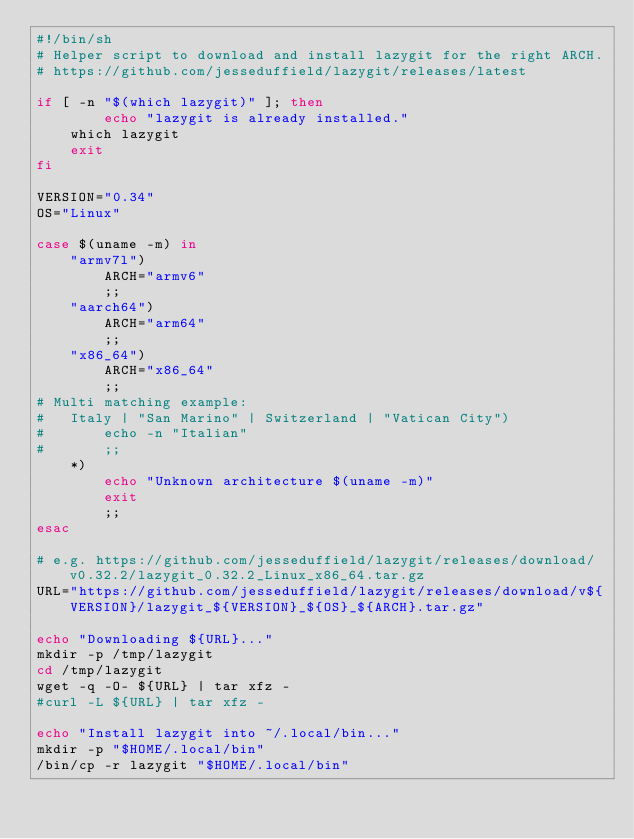<code> <loc_0><loc_0><loc_500><loc_500><_Bash_>#!/bin/sh
# Helper script to download and install lazygit for the right ARCH.
# https://github.com/jesseduffield/lazygit/releases/latest

if [ -n "$(which lazygit)" ]; then
        echo "lazygit is already installed."
	which lazygit
	exit
fi

VERSION="0.34"
OS="Linux"

case $(uname -m) in
	"armv7l")
		ARCH="armv6"
		;;
	"aarch64")
		ARCH="arm64"
		;;
	"x86_64")
		ARCH="x86_64"
		;;
# Multi matching example:
#	Italy | "San Marino" | Switzerland | "Vatican City")
#		echo -n "Italian"
#		;;
	*)
		echo "Unknown architecture $(uname -m)"
		exit
		;;
esac

# e.g. https://github.com/jesseduffield/lazygit/releases/download/v0.32.2/lazygit_0.32.2_Linux_x86_64.tar.gz
URL="https://github.com/jesseduffield/lazygit/releases/download/v${VERSION}/lazygit_${VERSION}_${OS}_${ARCH}.tar.gz"

echo "Downloading ${URL}..."
mkdir -p /tmp/lazygit
cd /tmp/lazygit
wget -q -O- ${URL} | tar xfz -
#curl -L ${URL} | tar xfz -

echo "Install lazygit into ~/.local/bin..."
mkdir -p "$HOME/.local/bin"
/bin/cp -r lazygit "$HOME/.local/bin"
</code> 